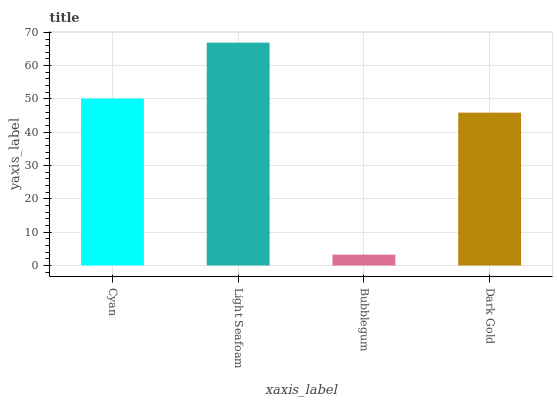Is Bubblegum the minimum?
Answer yes or no. Yes. Is Light Seafoam the maximum?
Answer yes or no. Yes. Is Light Seafoam the minimum?
Answer yes or no. No. Is Bubblegum the maximum?
Answer yes or no. No. Is Light Seafoam greater than Bubblegum?
Answer yes or no. Yes. Is Bubblegum less than Light Seafoam?
Answer yes or no. Yes. Is Bubblegum greater than Light Seafoam?
Answer yes or no. No. Is Light Seafoam less than Bubblegum?
Answer yes or no. No. Is Cyan the high median?
Answer yes or no. Yes. Is Dark Gold the low median?
Answer yes or no. Yes. Is Bubblegum the high median?
Answer yes or no. No. Is Light Seafoam the low median?
Answer yes or no. No. 